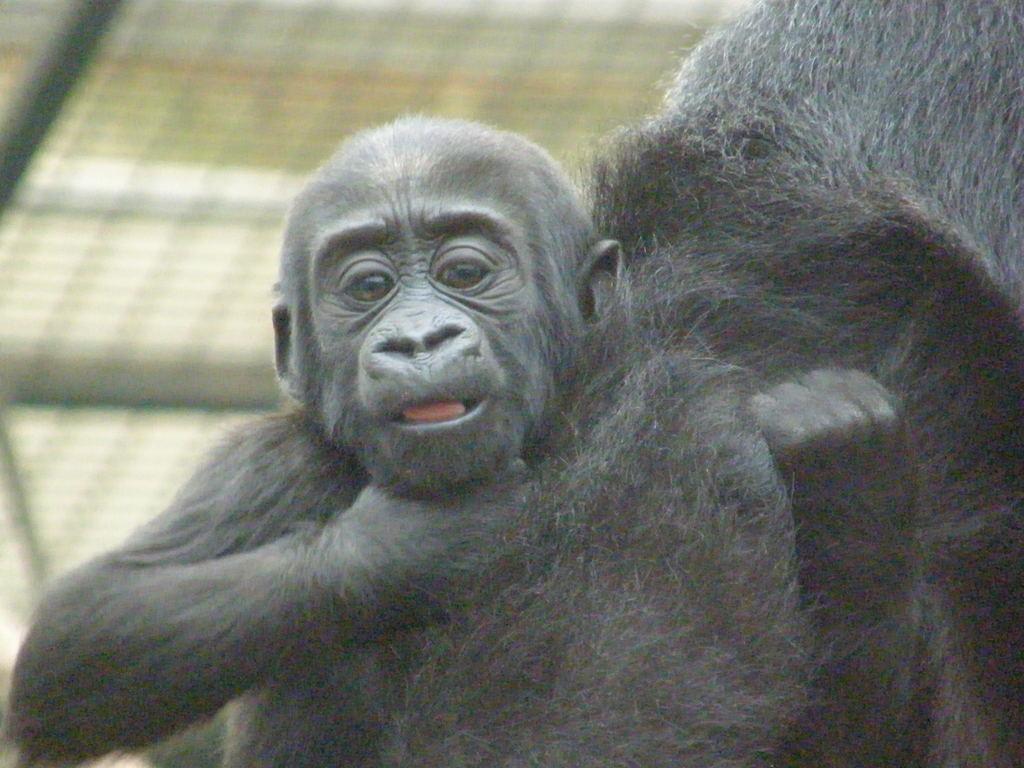Could you give a brief overview of what you see in this image? In this image there are two chimpanzees. At the back there is a fence. 